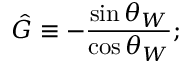<formula> <loc_0><loc_0><loc_500><loc_500>\hat { G } \equiv - \frac { \sin \theta _ { W } } { \cos \theta _ { W } } ;</formula> 